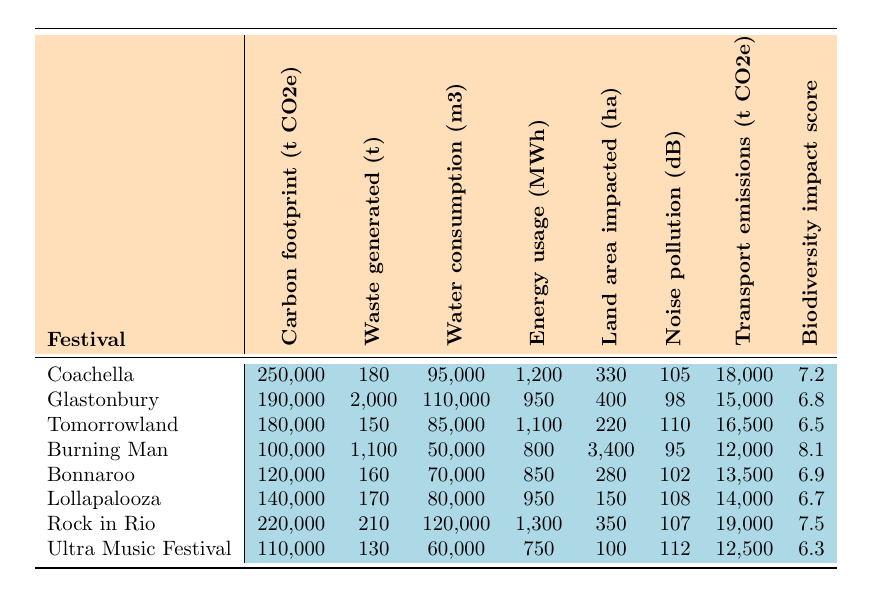What is the carbon footprint of Glastonbury? The carbon footprint for Glastonbury, as indicated in the table, is directly given as 190,000 tonnes CO2e.
Answer: 190,000 tonnes CO2e Which festival has the highest waste generated? By examining the waste generated column, Glastonbury has the highest amount at 2,000 tonnes.
Answer: Glastonbury What is the average water consumption across all festivals? To find the average water consumption, sum the water consumption values (95,000 + 110,000 + 85,000 + 50,000 + 70,000 + 80,000 + 120,000 + 60,000) = 620,000 m3. Then divide by the number of festivals (8), yielding an average of 620,000 / 8 = 77,500 m3.
Answer: 77,500 m3 Does Burning Man have the highest biodiversity impact score? Burning Man's biodiversity impact score is 8.1; comparing this to other festivals, it is indeed the highest score in the table.
Answer: Yes What is the difference in carbon footprint between Coachella and Ultra Music Festival? The carbon footprint for Coachella is 250,000 tonnes CO2e, and for Ultra Music Festival, it is 110,000 tonnes CO2e. The difference is calculated as 250,000 - 110,000 = 140,000 tonnes CO2e.
Answer: 140,000 tonnes CO2e Which festival has the lowest noise pollution? The lowest noise pollution value in the table is for Burning Man at 95 dB.
Answer: Burning Man What is the total energy usage for all the festivals combined? Adding the energy usage values (1,200 + 950 + 1,100 + 800 + 850 + 950 + 1,300 + 750) gives a total of 7,900 MWh for all festivals.
Answer: 7,900 MWh Are the transportation emissions from Tomorrowland greater than those from Bonnaroo? Tomorrowland's transportation emissions are 16,500 tonnes CO2e and Bonnaroo's are 13,500 tonnes CO2e. Since 16,500 is greater than 13,500, the statement is true.
Answer: Yes What is the median land area impacted among all festivals? To find the median, first list the land area impacted in order: 100, 150, 220, 280, 330, 350, 400, 3,400 hectares. The median is the average of the 4th and 5th values (280 + 330) / 2 = 305 hectares.
Answer: 305 hectares Is the average noise pollution level higher than 100 dB? The average of the noise pollution values (105 + 98 + 110 + 95 + 102 + 108 + 107 + 112) = 98.875 dB, which is not higher than 100 dB. Therefore, the statement is false.
Answer: No 